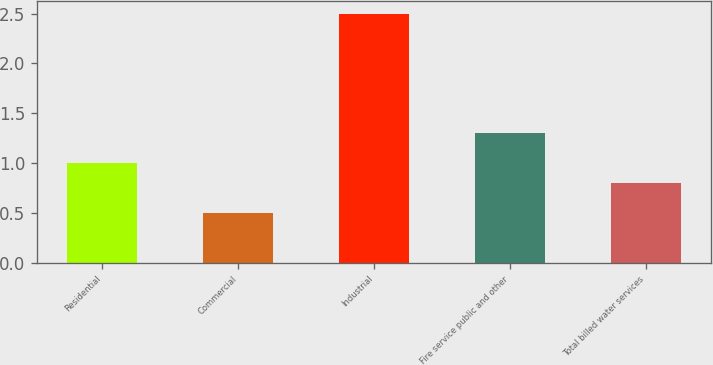Convert chart. <chart><loc_0><loc_0><loc_500><loc_500><bar_chart><fcel>Residential<fcel>Commercial<fcel>Industrial<fcel>Fire service public and other<fcel>Total billed water services<nl><fcel>1<fcel>0.5<fcel>2.5<fcel>1.3<fcel>0.8<nl></chart> 